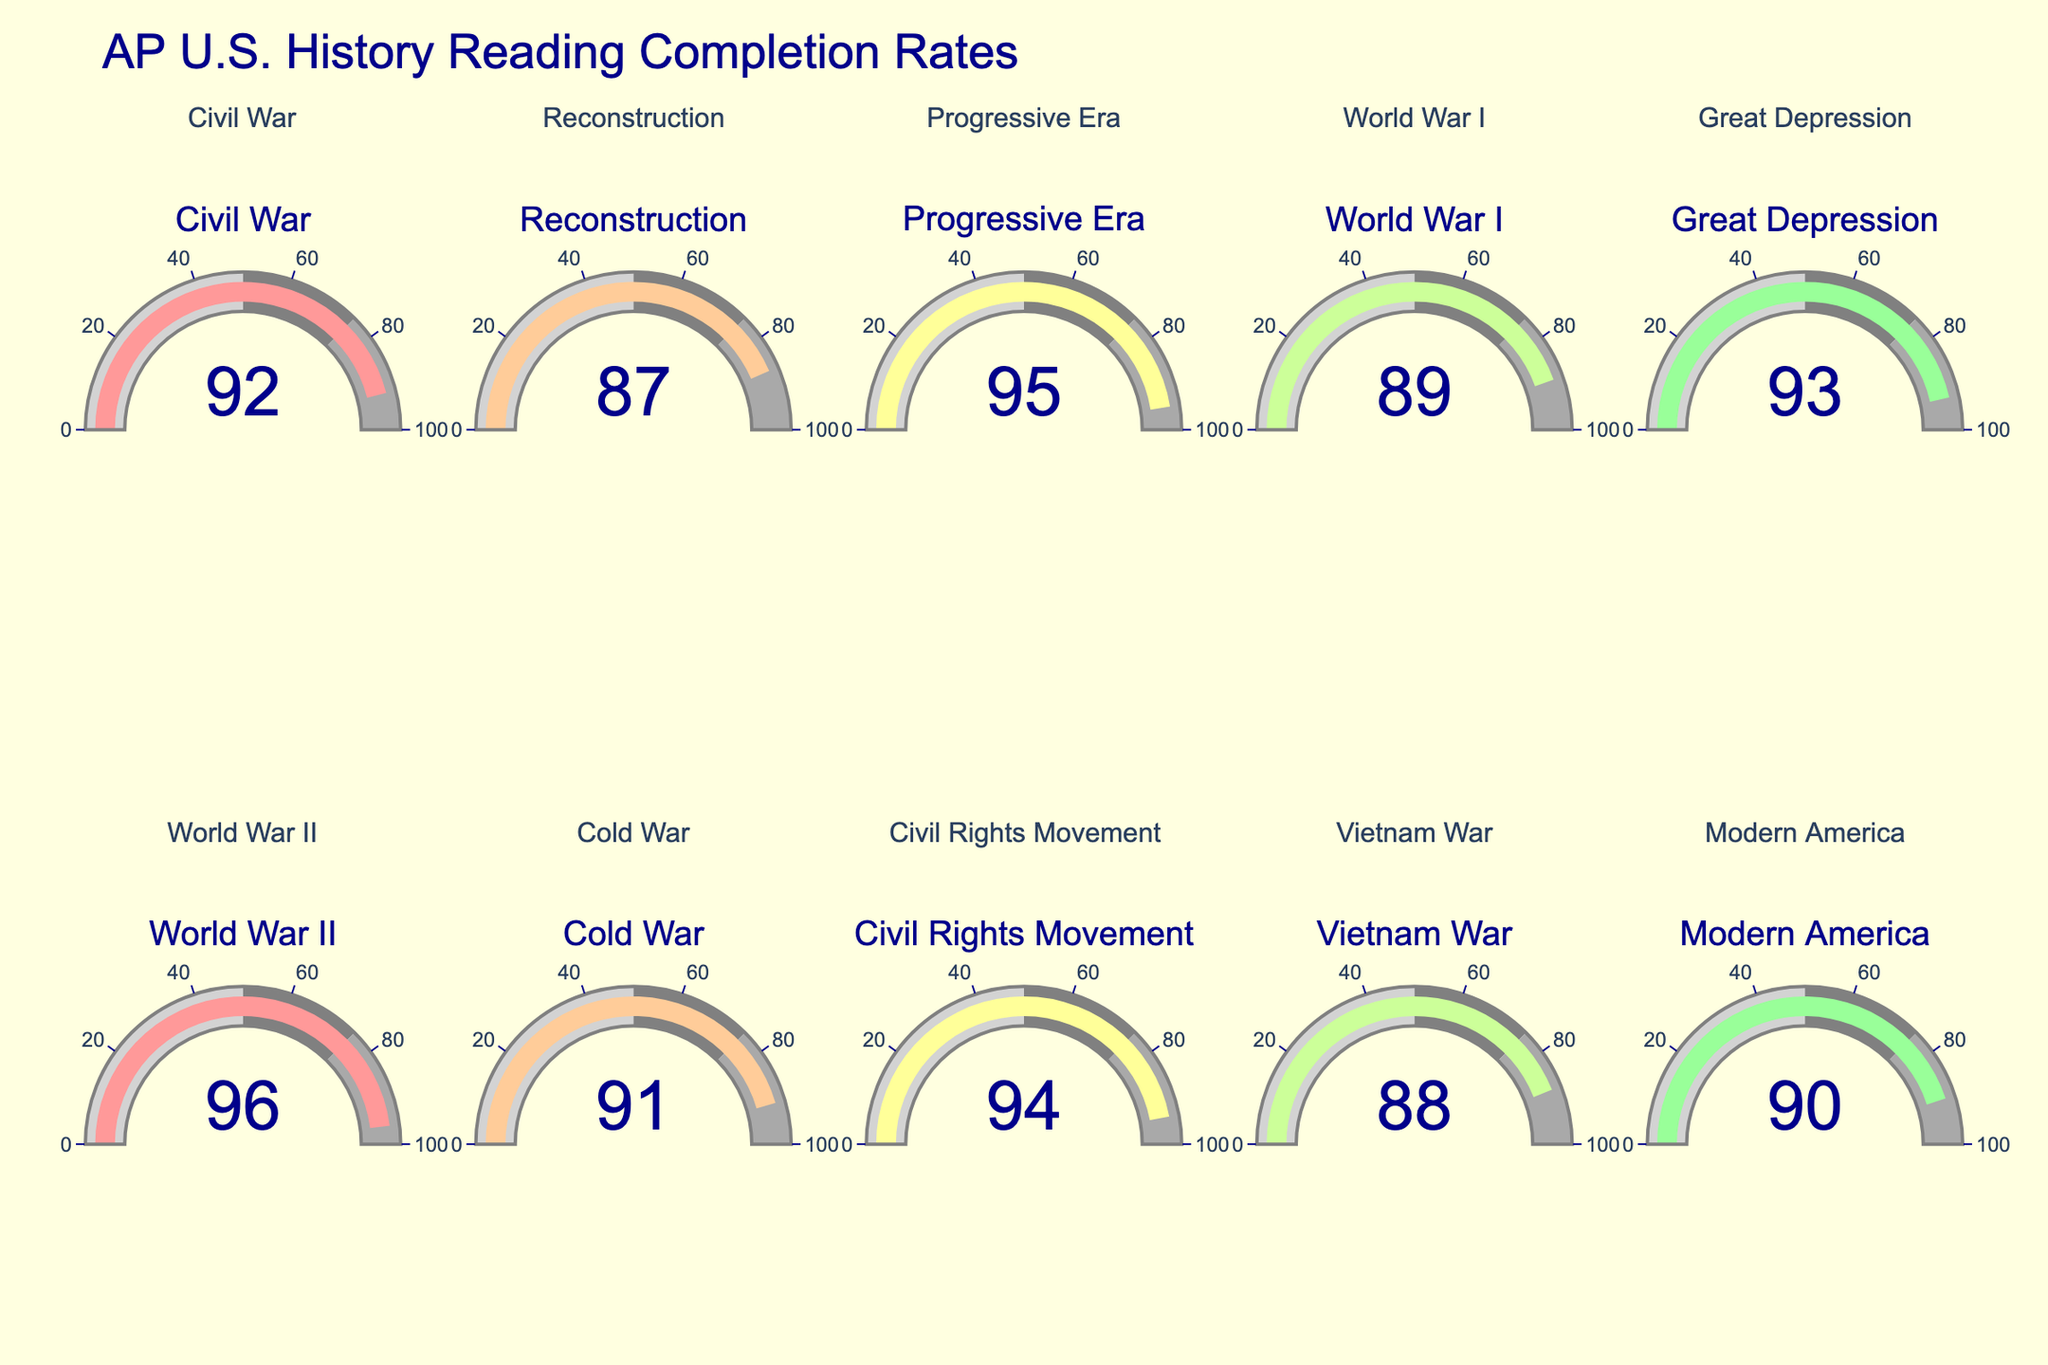What's the highest completion rate shown on the figure? To determine the highest completion rate, we need to look at each gauge and identify the highest value. The highest value displayed is 96, corresponding to the World War II chapter.
Answer: 96 What's the lowest completion rate among the chapters? We need to identify the smallest value shown on the gauges. The lowest value displayed is 87, which corresponds to the Reconstruction chapter.
Answer: 87 What is the average completion rate across all chapters? First, sum all the completion rates: 92 + 87 + 95 + 89 + 93 + 96 + 91 + 94 + 88 + 90 = 915. Then, divide by the number of chapters (10). Therefore, 915 / 10 = 91.5.
Answer: 91.5 Which chapter has a completion rate closest to 90? Look for the chapter with a completion rate closest to 90. The completion rates are: 92, 87, 95, 89, 93, 96, 91, 94, 88, 90. The value closest to 90 is the one for Modern America, which is exactly 90.
Answer: Modern America If we consider a completion rate above 90 as high, how many chapters have high completion rates? We need to count the chapters with completion rates above 90. The chapters with completion rates of 91, 92, 93, 94, 95, and 96. Thus, there are 6 chapters with high completion rates.
Answer: 6 Which chapter has the most similar completion rate to the Civil War chapter? The Civil War chapter has a completion rate of 92. We compare this to other completion rates: 87, 95, 89, 93, 96, 91, 94, 88, and 90. The completion rate closest to 92 is 91 for the Cold War chapter.
Answer: Cold War What's the range of completion rates? The range is calculated by subtracting the lowest completion rate from the highest completion rate. The highest is 96 (World War II) and the lowest is 87 (Reconstruction), so the range is 96 - 87 = 9.
Answer: 9 Which chapters have completion rates below 90? We need to identify chapters with completion rates less than 90. The chapters are Reconstruction (87), World War I (89), and Vietnam War (88). Therefore, 3 chapters have rates below 90.
Answer: 3 What's the median completion rate of the chapters? To find the median, list the rates in ascending order: 87, 88, 89, 90, 91, 92, 93, 94, 95, 96. There are 10 values, so the median is the average of the 5th and 6th values: (91 + 92) / 2 = 91.5.
Answer: 91.5 What is the completion rate difference between the Progressive Era and the Great Depression chapters? The completion rates are 95 for the Progressive Era and 93 for the Great Depression. The difference is 95 - 93 = 2.
Answer: 2 